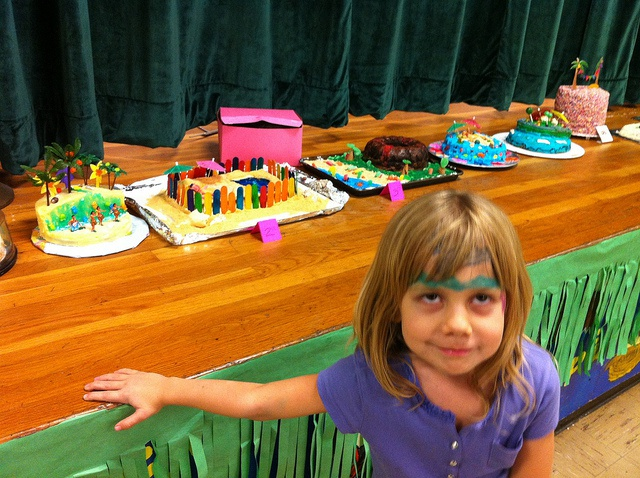Describe the objects in this image and their specific colors. I can see dining table in black, red, green, and orange tones, people in black, brown, tan, purple, and maroon tones, cake in black, red, orange, and khaki tones, cake in black, khaki, lightyellow, and lightgreen tones, and cake in black, salmon, white, and brown tones in this image. 